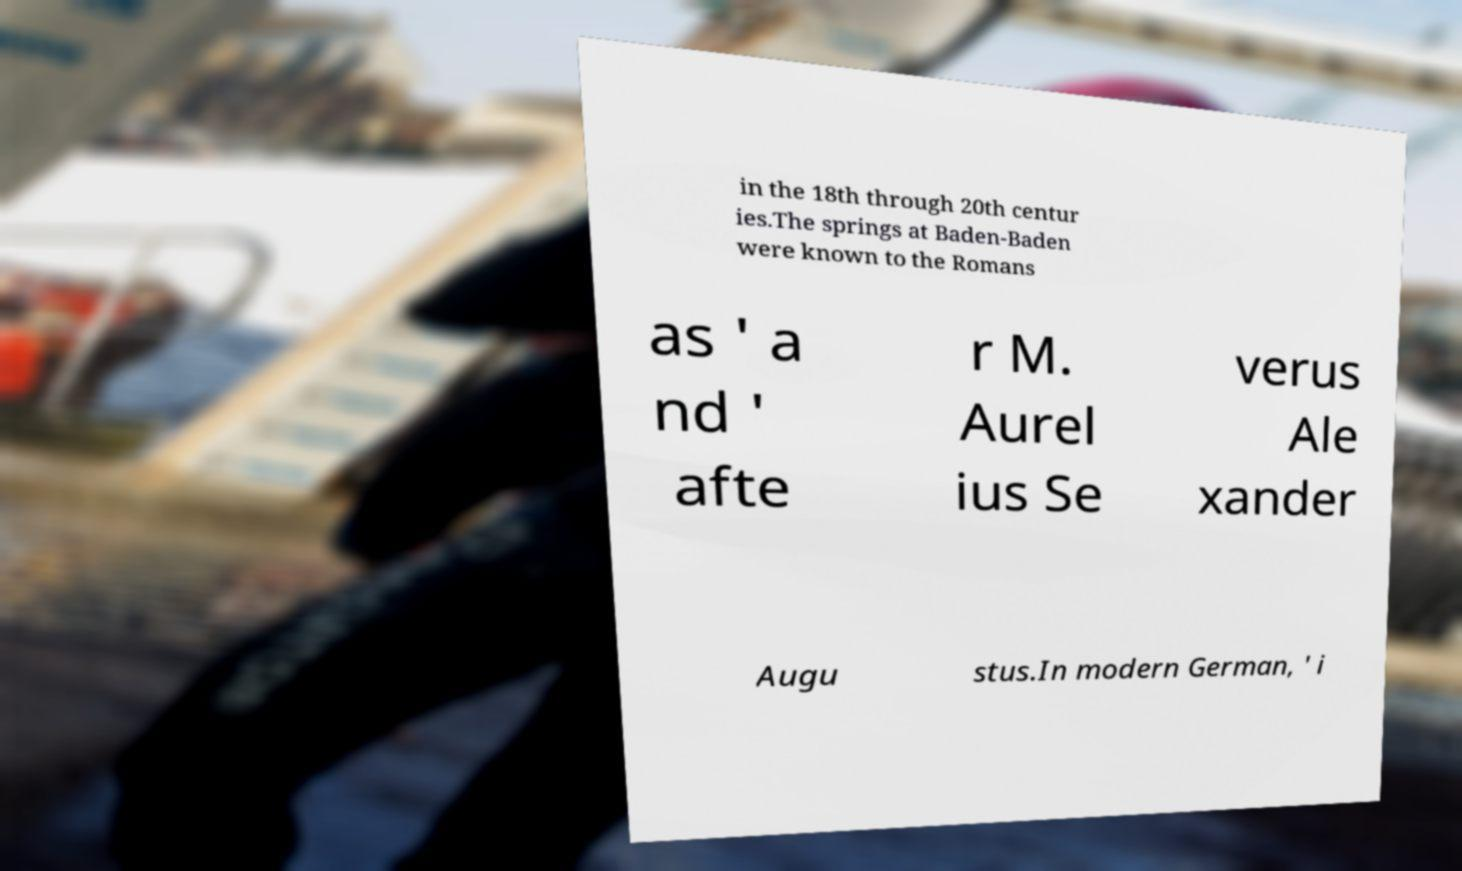Could you assist in decoding the text presented in this image and type it out clearly? in the 18th through 20th centur ies.The springs at Baden-Baden were known to the Romans as ' a nd ' afte r M. Aurel ius Se verus Ale xander Augu stus.In modern German, ' i 